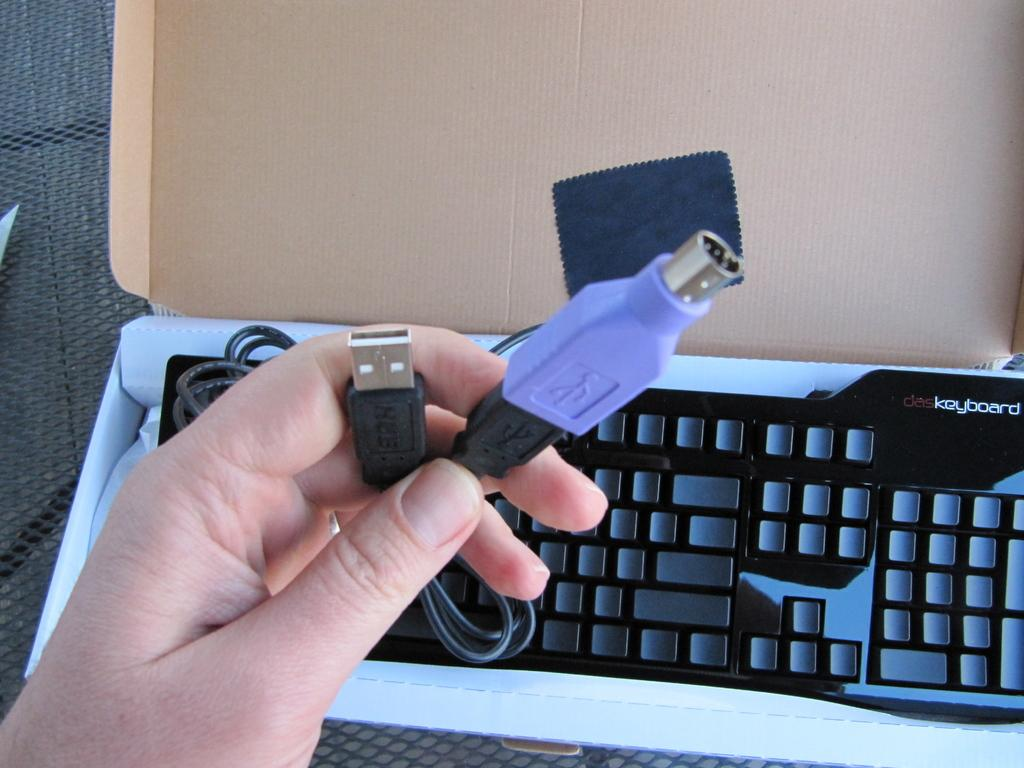<image>
Share a concise interpretation of the image provided. A DAS keyboards sits in a box on a table. 